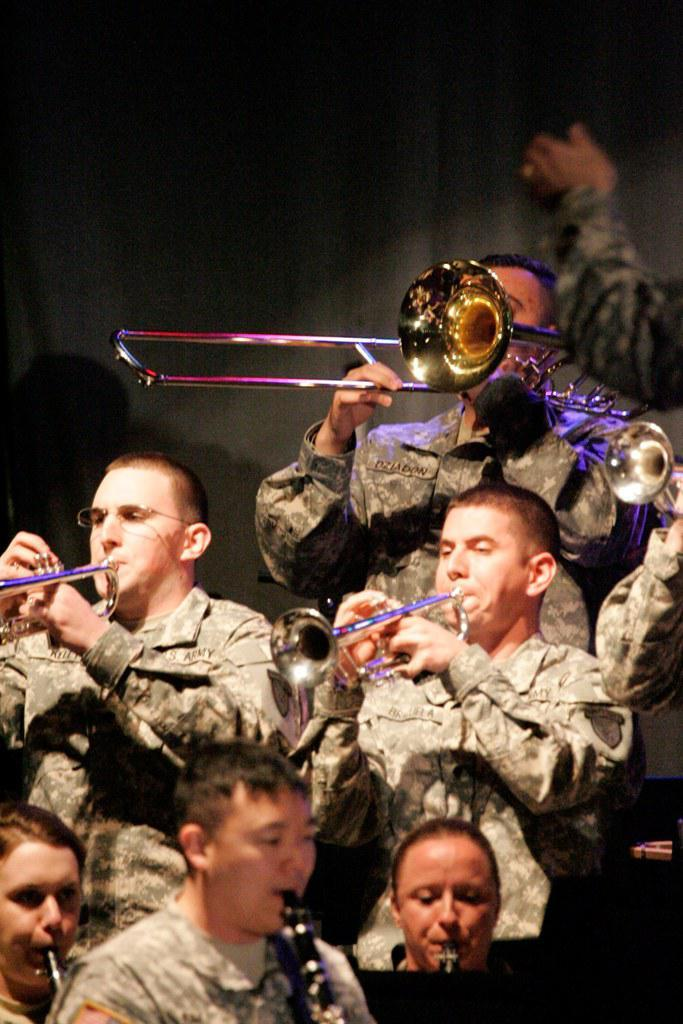Who or what can be seen in the image? There are people in the image. Where are the people located in the image? The people are standing in the center of the image. What are the people doing in the image? The people are playing trumpet instruments. What can be seen in the background of the image? There is a wall in the background of the image. Is there a spy sitting at a table near the stream in the image? There is no mention of a spy, table, or stream in the image. The image features people playing trumpet instruments and a wall in the background. 